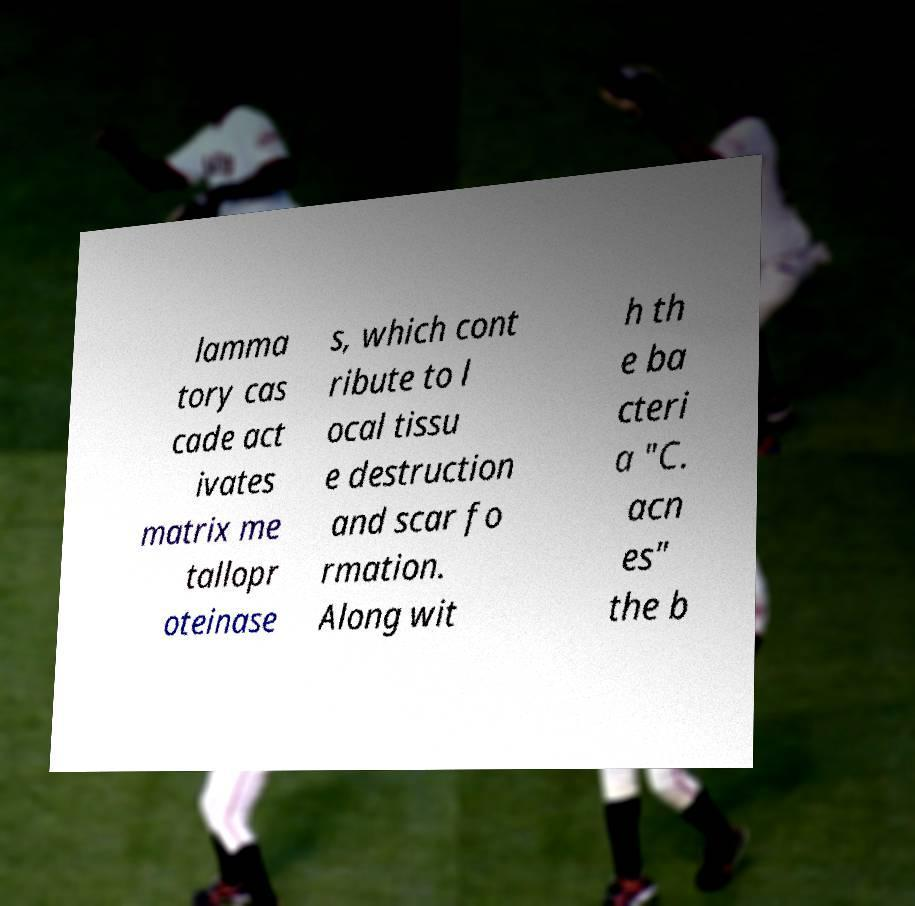For documentation purposes, I need the text within this image transcribed. Could you provide that? lamma tory cas cade act ivates matrix me tallopr oteinase s, which cont ribute to l ocal tissu e destruction and scar fo rmation. Along wit h th e ba cteri a "C. acn es" the b 